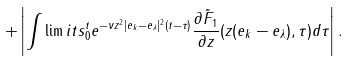<formula> <loc_0><loc_0><loc_500><loc_500>+ \left | \int \lim i t s _ { 0 } ^ { t } e ^ { - \nu z ^ { 2 } | e _ { k } - e _ { \lambda } | ^ { 2 } ( t - \tau ) } \frac { \partial { \tilde { F } _ { 1 } } } { \partial { z } } ( z ( e _ { k } - e _ { \lambda } ) , \tau ) d \tau \right | .</formula> 